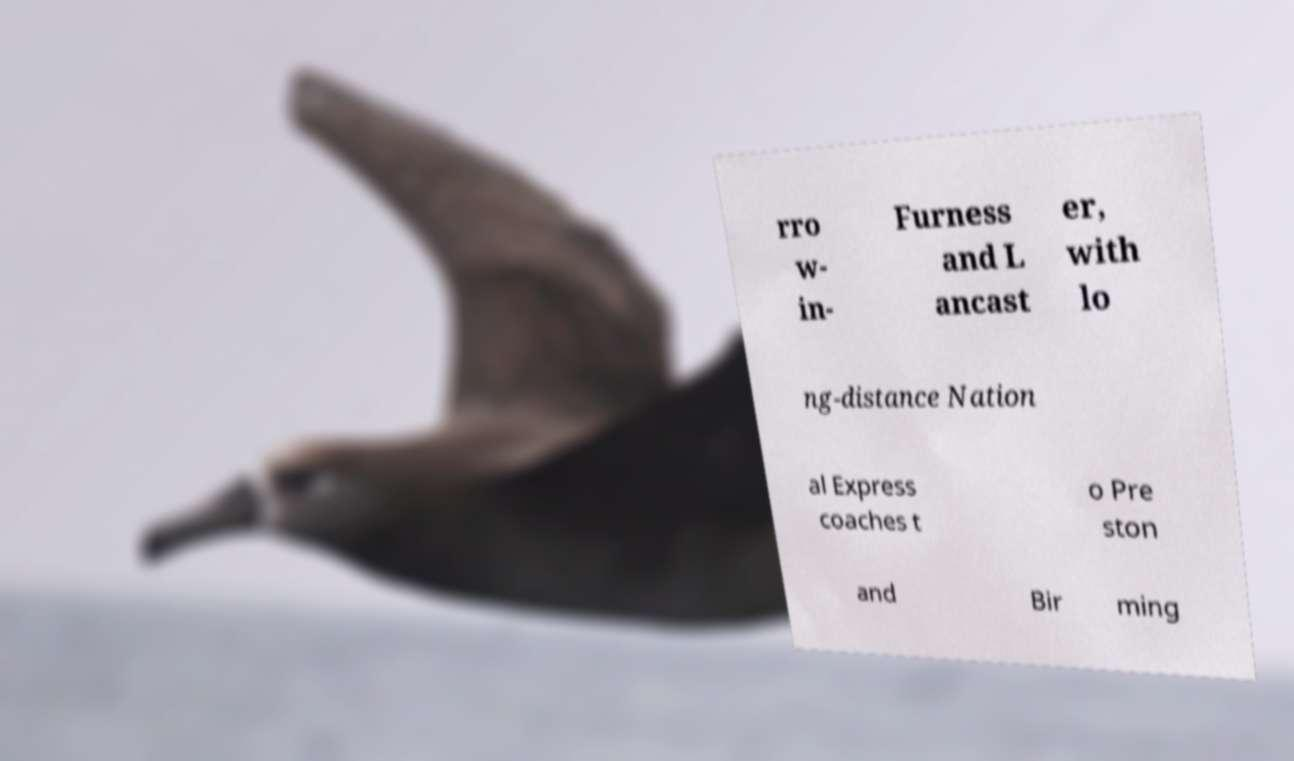Could you assist in decoding the text presented in this image and type it out clearly? rro w- in- Furness and L ancast er, with lo ng-distance Nation al Express coaches t o Pre ston and Bir ming 